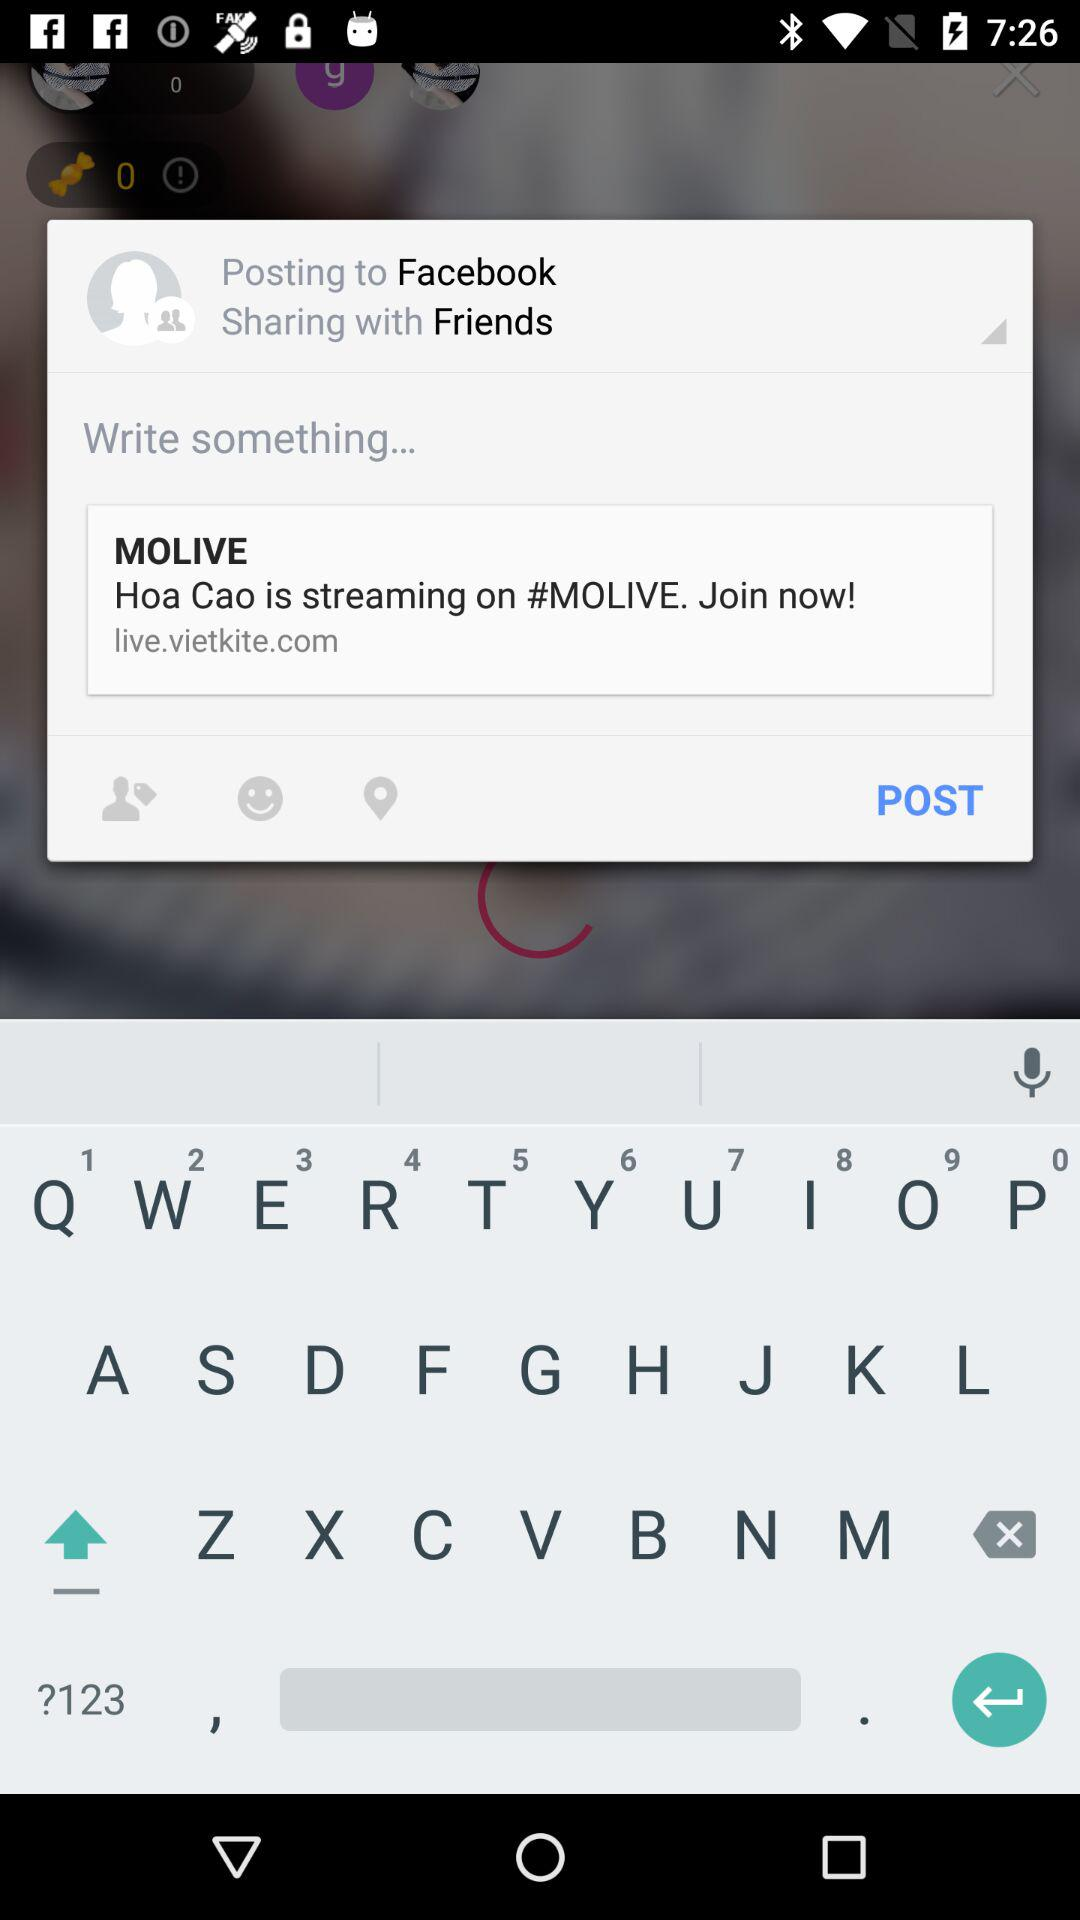What is the name of the user? The name of the user is John. 